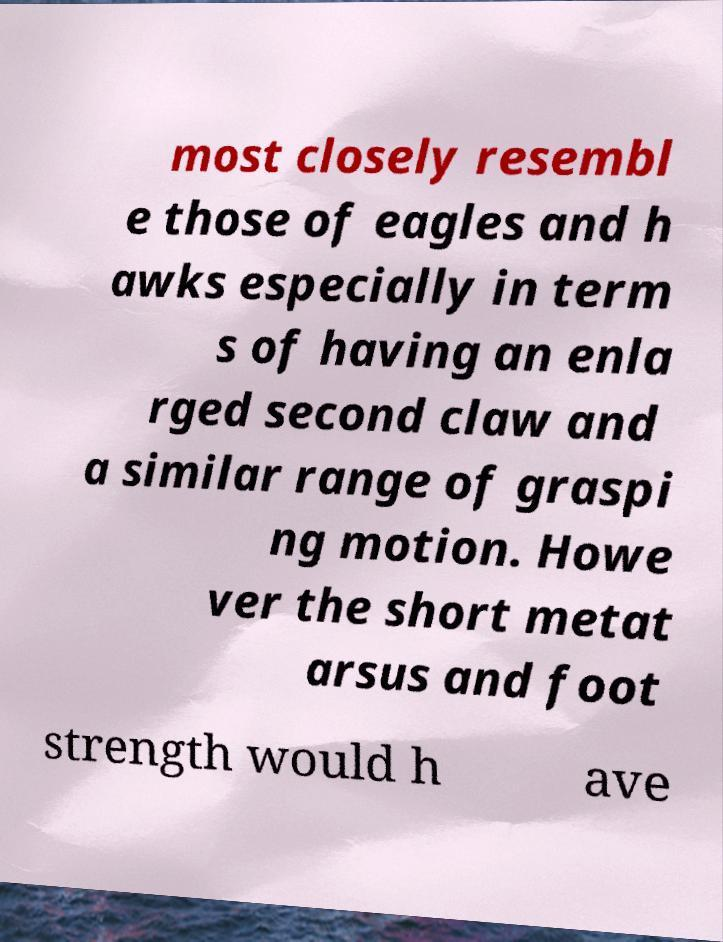I need the written content from this picture converted into text. Can you do that? most closely resembl e those of eagles and h awks especially in term s of having an enla rged second claw and a similar range of graspi ng motion. Howe ver the short metat arsus and foot strength would h ave 